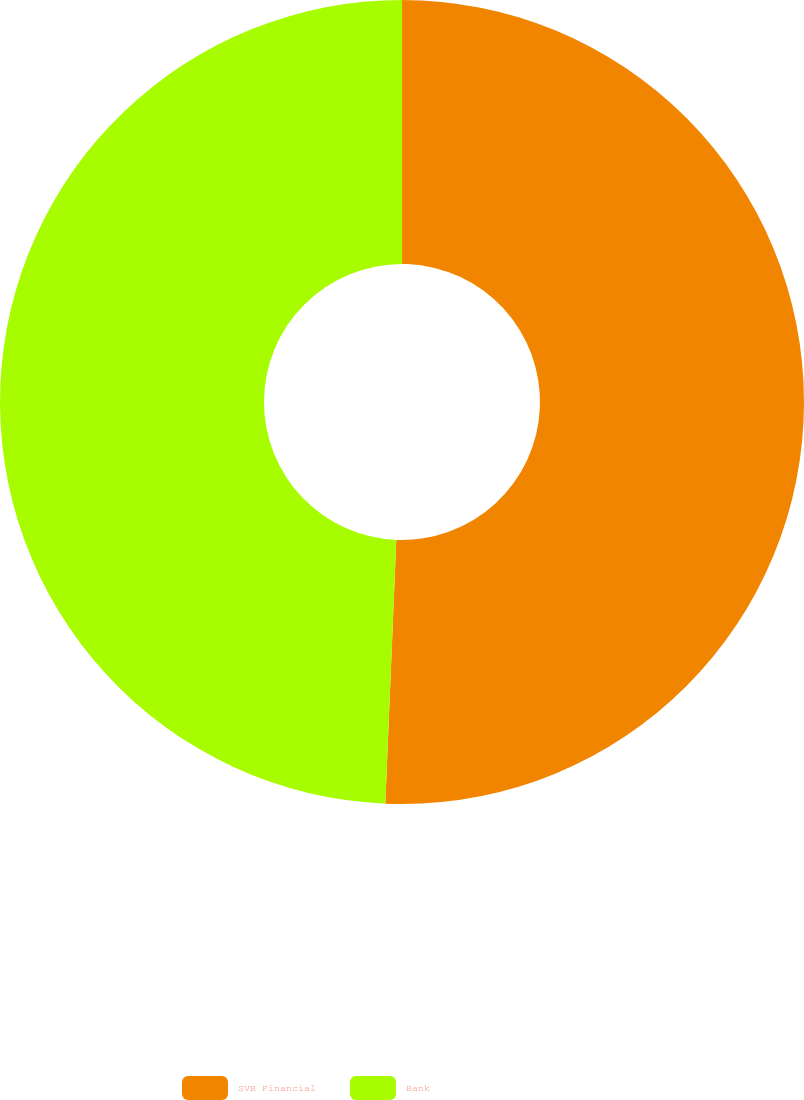Convert chart. <chart><loc_0><loc_0><loc_500><loc_500><pie_chart><fcel>SVB Financial<fcel>Bank<nl><fcel>50.66%<fcel>49.34%<nl></chart> 